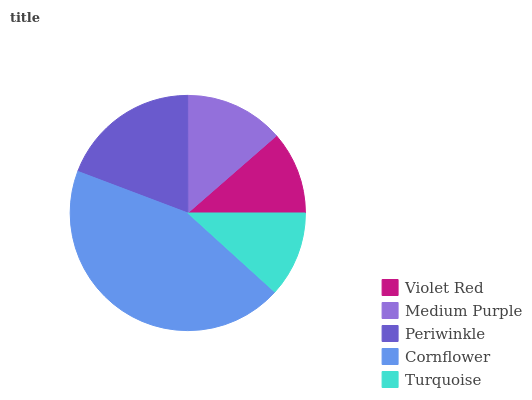Is Violet Red the minimum?
Answer yes or no. Yes. Is Cornflower the maximum?
Answer yes or no. Yes. Is Medium Purple the minimum?
Answer yes or no. No. Is Medium Purple the maximum?
Answer yes or no. No. Is Medium Purple greater than Violet Red?
Answer yes or no. Yes. Is Violet Red less than Medium Purple?
Answer yes or no. Yes. Is Violet Red greater than Medium Purple?
Answer yes or no. No. Is Medium Purple less than Violet Red?
Answer yes or no. No. Is Medium Purple the high median?
Answer yes or no. Yes. Is Medium Purple the low median?
Answer yes or no. Yes. Is Cornflower the high median?
Answer yes or no. No. Is Violet Red the low median?
Answer yes or no. No. 